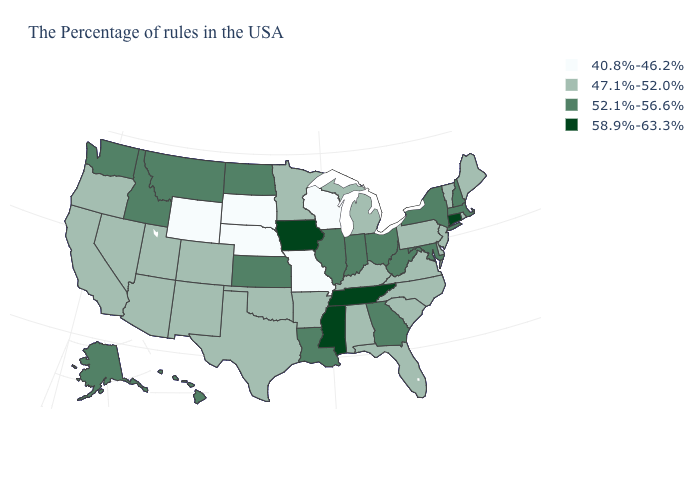What is the value of Georgia?
Write a very short answer. 52.1%-56.6%. What is the value of Louisiana?
Answer briefly. 52.1%-56.6%. What is the value of Illinois?
Keep it brief. 52.1%-56.6%. Among the states that border Indiana , does Illinois have the highest value?
Concise answer only. Yes. What is the value of Massachusetts?
Quick response, please. 52.1%-56.6%. Does Tennessee have the highest value in the USA?
Answer briefly. Yes. Does the map have missing data?
Answer briefly. No. Name the states that have a value in the range 40.8%-46.2%?
Write a very short answer. Wisconsin, Missouri, Nebraska, South Dakota, Wyoming. What is the lowest value in the USA?
Keep it brief. 40.8%-46.2%. Name the states that have a value in the range 47.1%-52.0%?
Give a very brief answer. Maine, Rhode Island, Vermont, New Jersey, Delaware, Pennsylvania, Virginia, North Carolina, South Carolina, Florida, Michigan, Kentucky, Alabama, Arkansas, Minnesota, Oklahoma, Texas, Colorado, New Mexico, Utah, Arizona, Nevada, California, Oregon. Name the states that have a value in the range 58.9%-63.3%?
Answer briefly. Connecticut, Tennessee, Mississippi, Iowa. What is the highest value in states that border Nebraska?
Short answer required. 58.9%-63.3%. Does Wisconsin have the lowest value in the MidWest?
Concise answer only. Yes. Among the states that border Oregon , does Washington have the highest value?
Short answer required. Yes. How many symbols are there in the legend?
Keep it brief. 4. 